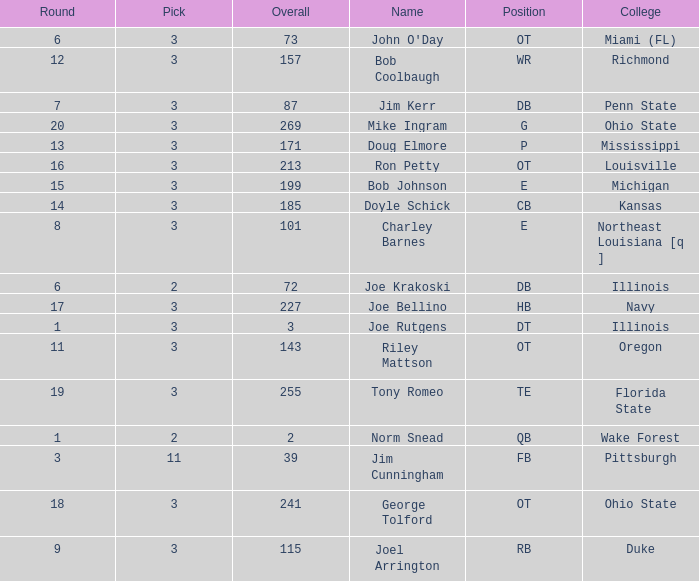Would you be able to parse every entry in this table? {'header': ['Round', 'Pick', 'Overall', 'Name', 'Position', 'College'], 'rows': [['6', '3', '73', "John O'Day", 'OT', 'Miami (FL)'], ['12', '3', '157', 'Bob Coolbaugh', 'WR', 'Richmond'], ['7', '3', '87', 'Jim Kerr', 'DB', 'Penn State'], ['20', '3', '269', 'Mike Ingram', 'G', 'Ohio State'], ['13', '3', '171', 'Doug Elmore', 'P', 'Mississippi'], ['16', '3', '213', 'Ron Petty', 'OT', 'Louisville'], ['15', '3', '199', 'Bob Johnson', 'E', 'Michigan'], ['14', '3', '185', 'Doyle Schick', 'CB', 'Kansas'], ['8', '3', '101', 'Charley Barnes', 'E', 'Northeast Louisiana [q ]'], ['6', '2', '72', 'Joe Krakoski', 'DB', 'Illinois'], ['17', '3', '227', 'Joe Bellino', 'HB', 'Navy'], ['1', '3', '3', 'Joe Rutgens', 'DT', 'Illinois'], ['11', '3', '143', 'Riley Mattson', 'OT', 'Oregon'], ['19', '3', '255', 'Tony Romeo', 'TE', 'Florida State'], ['1', '2', '2', 'Norm Snead', 'QB', 'Wake Forest'], ['3', '11', '39', 'Jim Cunningham', 'FB', 'Pittsburgh'], ['18', '3', '241', 'George Tolford', 'OT', 'Ohio State'], ['9', '3', '115', 'Joel Arrington', 'RB', 'Duke']]} How many rounds have john o'day as the name, and a pick less than 3? None. 